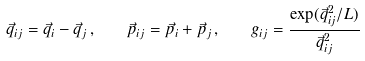<formula> <loc_0><loc_0><loc_500><loc_500>\vec { q } _ { i j } = \vec { q } _ { i } - \vec { q } _ { j } \, , \quad \vec { p } _ { i j } = \vec { p } _ { i } + \vec { p } _ { j } \, , \quad g _ { i j } = \frac { \exp ( \vec { q } ^ { 2 } _ { i j } / L ) } { \vec { q } ^ { 2 } _ { i j } }</formula> 